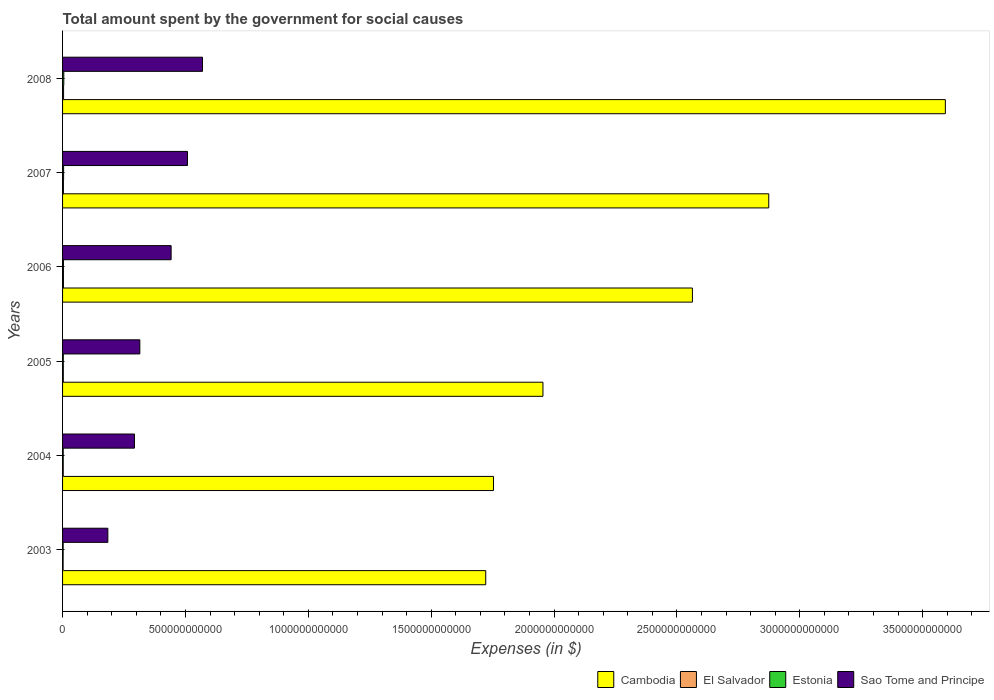Are the number of bars per tick equal to the number of legend labels?
Provide a succinct answer. Yes. Are the number of bars on each tick of the Y-axis equal?
Your answer should be compact. Yes. How many bars are there on the 4th tick from the bottom?
Ensure brevity in your answer.  4. In how many cases, is the number of bars for a given year not equal to the number of legend labels?
Offer a terse response. 0. What is the amount spent for social causes by the government in Estonia in 2005?
Offer a terse response. 2.99e+09. Across all years, what is the maximum amount spent for social causes by the government in Sao Tome and Principe?
Your answer should be compact. 5.69e+11. Across all years, what is the minimum amount spent for social causes by the government in Estonia?
Ensure brevity in your answer.  2.40e+09. In which year was the amount spent for social causes by the government in Estonia minimum?
Your answer should be compact. 2003. What is the total amount spent for social causes by the government in El Salvador in the graph?
Provide a succinct answer. 1.92e+1. What is the difference between the amount spent for social causes by the government in El Salvador in 2003 and that in 2006?
Keep it short and to the point. -1.31e+09. What is the difference between the amount spent for social causes by the government in Estonia in 2004 and the amount spent for social causes by the government in El Salvador in 2006?
Give a very brief answer. -9.47e+08. What is the average amount spent for social causes by the government in Cambodia per year?
Ensure brevity in your answer.  2.41e+12. In the year 2003, what is the difference between the amount spent for social causes by the government in Cambodia and amount spent for social causes by the government in Sao Tome and Principe?
Offer a very short reply. 1.54e+12. In how many years, is the amount spent for social causes by the government in El Salvador greater than 800000000000 $?
Ensure brevity in your answer.  0. What is the ratio of the amount spent for social causes by the government in Cambodia in 2004 to that in 2005?
Provide a succinct answer. 0.9. What is the difference between the highest and the second highest amount spent for social causes by the government in El Salvador?
Your answer should be compact. 4.88e+08. What is the difference between the highest and the lowest amount spent for social causes by the government in Cambodia?
Provide a succinct answer. 1.87e+12. In how many years, is the amount spent for social causes by the government in Sao Tome and Principe greater than the average amount spent for social causes by the government in Sao Tome and Principe taken over all years?
Ensure brevity in your answer.  3. Is the sum of the amount spent for social causes by the government in Sao Tome and Principe in 2005 and 2008 greater than the maximum amount spent for social causes by the government in Estonia across all years?
Keep it short and to the point. Yes. What does the 4th bar from the top in 2006 represents?
Provide a succinct answer. Cambodia. What does the 2nd bar from the bottom in 2004 represents?
Your answer should be very brief. El Salvador. Is it the case that in every year, the sum of the amount spent for social causes by the government in El Salvador and amount spent for social causes by the government in Estonia is greater than the amount spent for social causes by the government in Sao Tome and Principe?
Your response must be concise. No. How many years are there in the graph?
Provide a short and direct response. 6. What is the difference between two consecutive major ticks on the X-axis?
Your answer should be compact. 5.00e+11. Are the values on the major ticks of X-axis written in scientific E-notation?
Provide a short and direct response. No. Does the graph contain grids?
Your response must be concise. No. Where does the legend appear in the graph?
Give a very brief answer. Bottom right. How many legend labels are there?
Offer a very short reply. 4. How are the legend labels stacked?
Your answer should be compact. Horizontal. What is the title of the graph?
Offer a very short reply. Total amount spent by the government for social causes. What is the label or title of the X-axis?
Your answer should be compact. Expenses (in $). What is the Expenses (in $) in Cambodia in 2003?
Offer a very short reply. 1.72e+12. What is the Expenses (in $) in El Salvador in 2003?
Give a very brief answer. 2.30e+09. What is the Expenses (in $) of Estonia in 2003?
Offer a very short reply. 2.40e+09. What is the Expenses (in $) of Sao Tome and Principe in 2003?
Provide a short and direct response. 1.84e+11. What is the Expenses (in $) in Cambodia in 2004?
Your response must be concise. 1.75e+12. What is the Expenses (in $) in El Salvador in 2004?
Your response must be concise. 2.69e+09. What is the Expenses (in $) of Estonia in 2004?
Offer a terse response. 2.66e+09. What is the Expenses (in $) of Sao Tome and Principe in 2004?
Keep it short and to the point. 2.93e+11. What is the Expenses (in $) of Cambodia in 2005?
Your answer should be compact. 1.95e+12. What is the Expenses (in $) of El Salvador in 2005?
Provide a short and direct response. 3.01e+09. What is the Expenses (in $) of Estonia in 2005?
Your answer should be very brief. 2.99e+09. What is the Expenses (in $) of Sao Tome and Principe in 2005?
Offer a terse response. 3.14e+11. What is the Expenses (in $) in Cambodia in 2006?
Your response must be concise. 2.56e+12. What is the Expenses (in $) in El Salvador in 2006?
Your response must be concise. 3.60e+09. What is the Expenses (in $) of Estonia in 2006?
Offer a very short reply. 3.56e+09. What is the Expenses (in $) of Sao Tome and Principe in 2006?
Your answer should be very brief. 4.42e+11. What is the Expenses (in $) of Cambodia in 2007?
Give a very brief answer. 2.87e+12. What is the Expenses (in $) of El Salvador in 2007?
Your answer should be very brief. 3.49e+09. What is the Expenses (in $) of Estonia in 2007?
Your response must be concise. 4.25e+09. What is the Expenses (in $) in Sao Tome and Principe in 2007?
Your answer should be compact. 5.08e+11. What is the Expenses (in $) in Cambodia in 2008?
Ensure brevity in your answer.  3.59e+12. What is the Expenses (in $) in El Salvador in 2008?
Provide a short and direct response. 4.09e+09. What is the Expenses (in $) of Estonia in 2008?
Make the answer very short. 5.00e+09. What is the Expenses (in $) of Sao Tome and Principe in 2008?
Provide a succinct answer. 5.69e+11. Across all years, what is the maximum Expenses (in $) of Cambodia?
Offer a terse response. 3.59e+12. Across all years, what is the maximum Expenses (in $) of El Salvador?
Keep it short and to the point. 4.09e+09. Across all years, what is the maximum Expenses (in $) in Estonia?
Keep it short and to the point. 5.00e+09. Across all years, what is the maximum Expenses (in $) in Sao Tome and Principe?
Make the answer very short. 5.69e+11. Across all years, what is the minimum Expenses (in $) of Cambodia?
Offer a very short reply. 1.72e+12. Across all years, what is the minimum Expenses (in $) of El Salvador?
Provide a short and direct response. 2.30e+09. Across all years, what is the minimum Expenses (in $) in Estonia?
Your answer should be very brief. 2.40e+09. Across all years, what is the minimum Expenses (in $) of Sao Tome and Principe?
Give a very brief answer. 1.84e+11. What is the total Expenses (in $) of Cambodia in the graph?
Keep it short and to the point. 1.45e+13. What is the total Expenses (in $) in El Salvador in the graph?
Provide a succinct answer. 1.92e+1. What is the total Expenses (in $) in Estonia in the graph?
Provide a succinct answer. 2.09e+1. What is the total Expenses (in $) in Sao Tome and Principe in the graph?
Keep it short and to the point. 2.31e+12. What is the difference between the Expenses (in $) of Cambodia in 2003 and that in 2004?
Make the answer very short. -3.16e+1. What is the difference between the Expenses (in $) of El Salvador in 2003 and that in 2004?
Offer a terse response. -3.95e+08. What is the difference between the Expenses (in $) of Estonia in 2003 and that in 2004?
Provide a succinct answer. -2.58e+08. What is the difference between the Expenses (in $) in Sao Tome and Principe in 2003 and that in 2004?
Ensure brevity in your answer.  -1.08e+11. What is the difference between the Expenses (in $) of Cambodia in 2003 and that in 2005?
Your response must be concise. -2.33e+11. What is the difference between the Expenses (in $) in El Salvador in 2003 and that in 2005?
Provide a succinct answer. -7.12e+08. What is the difference between the Expenses (in $) of Estonia in 2003 and that in 2005?
Your answer should be compact. -5.91e+08. What is the difference between the Expenses (in $) in Sao Tome and Principe in 2003 and that in 2005?
Make the answer very short. -1.30e+11. What is the difference between the Expenses (in $) of Cambodia in 2003 and that in 2006?
Your answer should be compact. -8.41e+11. What is the difference between the Expenses (in $) in El Salvador in 2003 and that in 2006?
Provide a short and direct response. -1.31e+09. What is the difference between the Expenses (in $) of Estonia in 2003 and that in 2006?
Keep it short and to the point. -1.16e+09. What is the difference between the Expenses (in $) in Sao Tome and Principe in 2003 and that in 2006?
Your response must be concise. -2.58e+11. What is the difference between the Expenses (in $) in Cambodia in 2003 and that in 2007?
Your answer should be very brief. -1.15e+12. What is the difference between the Expenses (in $) in El Salvador in 2003 and that in 2007?
Give a very brief answer. -1.20e+09. What is the difference between the Expenses (in $) of Estonia in 2003 and that in 2007?
Make the answer very short. -1.85e+09. What is the difference between the Expenses (in $) of Sao Tome and Principe in 2003 and that in 2007?
Ensure brevity in your answer.  -3.24e+11. What is the difference between the Expenses (in $) in Cambodia in 2003 and that in 2008?
Your answer should be compact. -1.87e+12. What is the difference between the Expenses (in $) of El Salvador in 2003 and that in 2008?
Ensure brevity in your answer.  -1.80e+09. What is the difference between the Expenses (in $) in Estonia in 2003 and that in 2008?
Your answer should be compact. -2.60e+09. What is the difference between the Expenses (in $) in Sao Tome and Principe in 2003 and that in 2008?
Provide a succinct answer. -3.85e+11. What is the difference between the Expenses (in $) in Cambodia in 2004 and that in 2005?
Keep it short and to the point. -2.01e+11. What is the difference between the Expenses (in $) of El Salvador in 2004 and that in 2005?
Ensure brevity in your answer.  -3.17e+08. What is the difference between the Expenses (in $) in Estonia in 2004 and that in 2005?
Provide a succinct answer. -3.34e+08. What is the difference between the Expenses (in $) in Sao Tome and Principe in 2004 and that in 2005?
Provide a short and direct response. -2.18e+1. What is the difference between the Expenses (in $) of Cambodia in 2004 and that in 2006?
Keep it short and to the point. -8.10e+11. What is the difference between the Expenses (in $) in El Salvador in 2004 and that in 2006?
Give a very brief answer. -9.12e+08. What is the difference between the Expenses (in $) in Estonia in 2004 and that in 2006?
Provide a succinct answer. -9.03e+08. What is the difference between the Expenses (in $) in Sao Tome and Principe in 2004 and that in 2006?
Your answer should be very brief. -1.49e+11. What is the difference between the Expenses (in $) in Cambodia in 2004 and that in 2007?
Your answer should be very brief. -1.12e+12. What is the difference between the Expenses (in $) of El Salvador in 2004 and that in 2007?
Give a very brief answer. -8.02e+08. What is the difference between the Expenses (in $) of Estonia in 2004 and that in 2007?
Make the answer very short. -1.59e+09. What is the difference between the Expenses (in $) of Sao Tome and Principe in 2004 and that in 2007?
Your response must be concise. -2.16e+11. What is the difference between the Expenses (in $) of Cambodia in 2004 and that in 2008?
Give a very brief answer. -1.84e+12. What is the difference between the Expenses (in $) in El Salvador in 2004 and that in 2008?
Offer a terse response. -1.40e+09. What is the difference between the Expenses (in $) of Estonia in 2004 and that in 2008?
Give a very brief answer. -2.35e+09. What is the difference between the Expenses (in $) of Sao Tome and Principe in 2004 and that in 2008?
Ensure brevity in your answer.  -2.77e+11. What is the difference between the Expenses (in $) in Cambodia in 2005 and that in 2006?
Keep it short and to the point. -6.08e+11. What is the difference between the Expenses (in $) in El Salvador in 2005 and that in 2006?
Make the answer very short. -5.95e+08. What is the difference between the Expenses (in $) in Estonia in 2005 and that in 2006?
Your answer should be compact. -5.69e+08. What is the difference between the Expenses (in $) in Sao Tome and Principe in 2005 and that in 2006?
Offer a very short reply. -1.27e+11. What is the difference between the Expenses (in $) of Cambodia in 2005 and that in 2007?
Ensure brevity in your answer.  -9.19e+11. What is the difference between the Expenses (in $) in El Salvador in 2005 and that in 2007?
Your answer should be compact. -4.85e+08. What is the difference between the Expenses (in $) of Estonia in 2005 and that in 2007?
Your answer should be compact. -1.26e+09. What is the difference between the Expenses (in $) of Sao Tome and Principe in 2005 and that in 2007?
Your answer should be very brief. -1.94e+11. What is the difference between the Expenses (in $) in Cambodia in 2005 and that in 2008?
Offer a very short reply. -1.64e+12. What is the difference between the Expenses (in $) in El Salvador in 2005 and that in 2008?
Offer a very short reply. -1.08e+09. What is the difference between the Expenses (in $) in Estonia in 2005 and that in 2008?
Keep it short and to the point. -2.01e+09. What is the difference between the Expenses (in $) of Sao Tome and Principe in 2005 and that in 2008?
Provide a succinct answer. -2.55e+11. What is the difference between the Expenses (in $) of Cambodia in 2006 and that in 2007?
Offer a terse response. -3.11e+11. What is the difference between the Expenses (in $) of El Salvador in 2006 and that in 2007?
Your response must be concise. 1.10e+08. What is the difference between the Expenses (in $) in Estonia in 2006 and that in 2007?
Provide a short and direct response. -6.92e+08. What is the difference between the Expenses (in $) of Sao Tome and Principe in 2006 and that in 2007?
Offer a very short reply. -6.67e+1. What is the difference between the Expenses (in $) of Cambodia in 2006 and that in 2008?
Ensure brevity in your answer.  -1.03e+12. What is the difference between the Expenses (in $) of El Salvador in 2006 and that in 2008?
Provide a short and direct response. -4.88e+08. What is the difference between the Expenses (in $) in Estonia in 2006 and that in 2008?
Your answer should be very brief. -1.44e+09. What is the difference between the Expenses (in $) of Sao Tome and Principe in 2006 and that in 2008?
Offer a terse response. -1.28e+11. What is the difference between the Expenses (in $) in Cambodia in 2007 and that in 2008?
Provide a short and direct response. -7.19e+11. What is the difference between the Expenses (in $) of El Salvador in 2007 and that in 2008?
Offer a very short reply. -5.98e+08. What is the difference between the Expenses (in $) in Estonia in 2007 and that in 2008?
Your answer should be very brief. -7.51e+08. What is the difference between the Expenses (in $) of Sao Tome and Principe in 2007 and that in 2008?
Offer a terse response. -6.10e+1. What is the difference between the Expenses (in $) in Cambodia in 2003 and the Expenses (in $) in El Salvador in 2004?
Give a very brief answer. 1.72e+12. What is the difference between the Expenses (in $) of Cambodia in 2003 and the Expenses (in $) of Estonia in 2004?
Make the answer very short. 1.72e+12. What is the difference between the Expenses (in $) in Cambodia in 2003 and the Expenses (in $) in Sao Tome and Principe in 2004?
Provide a short and direct response. 1.43e+12. What is the difference between the Expenses (in $) in El Salvador in 2003 and the Expenses (in $) in Estonia in 2004?
Offer a terse response. -3.60e+08. What is the difference between the Expenses (in $) of El Salvador in 2003 and the Expenses (in $) of Sao Tome and Principe in 2004?
Make the answer very short. -2.90e+11. What is the difference between the Expenses (in $) of Estonia in 2003 and the Expenses (in $) of Sao Tome and Principe in 2004?
Provide a short and direct response. -2.90e+11. What is the difference between the Expenses (in $) of Cambodia in 2003 and the Expenses (in $) of El Salvador in 2005?
Your answer should be compact. 1.72e+12. What is the difference between the Expenses (in $) in Cambodia in 2003 and the Expenses (in $) in Estonia in 2005?
Provide a succinct answer. 1.72e+12. What is the difference between the Expenses (in $) in Cambodia in 2003 and the Expenses (in $) in Sao Tome and Principe in 2005?
Your answer should be compact. 1.41e+12. What is the difference between the Expenses (in $) in El Salvador in 2003 and the Expenses (in $) in Estonia in 2005?
Make the answer very short. -6.94e+08. What is the difference between the Expenses (in $) of El Salvador in 2003 and the Expenses (in $) of Sao Tome and Principe in 2005?
Give a very brief answer. -3.12e+11. What is the difference between the Expenses (in $) of Estonia in 2003 and the Expenses (in $) of Sao Tome and Principe in 2005?
Give a very brief answer. -3.12e+11. What is the difference between the Expenses (in $) of Cambodia in 2003 and the Expenses (in $) of El Salvador in 2006?
Offer a very short reply. 1.72e+12. What is the difference between the Expenses (in $) in Cambodia in 2003 and the Expenses (in $) in Estonia in 2006?
Offer a very short reply. 1.72e+12. What is the difference between the Expenses (in $) of Cambodia in 2003 and the Expenses (in $) of Sao Tome and Principe in 2006?
Your response must be concise. 1.28e+12. What is the difference between the Expenses (in $) of El Salvador in 2003 and the Expenses (in $) of Estonia in 2006?
Provide a succinct answer. -1.26e+09. What is the difference between the Expenses (in $) in El Salvador in 2003 and the Expenses (in $) in Sao Tome and Principe in 2006?
Offer a very short reply. -4.39e+11. What is the difference between the Expenses (in $) of Estonia in 2003 and the Expenses (in $) of Sao Tome and Principe in 2006?
Keep it short and to the point. -4.39e+11. What is the difference between the Expenses (in $) of Cambodia in 2003 and the Expenses (in $) of El Salvador in 2007?
Your answer should be compact. 1.72e+12. What is the difference between the Expenses (in $) of Cambodia in 2003 and the Expenses (in $) of Estonia in 2007?
Provide a succinct answer. 1.72e+12. What is the difference between the Expenses (in $) of Cambodia in 2003 and the Expenses (in $) of Sao Tome and Principe in 2007?
Give a very brief answer. 1.21e+12. What is the difference between the Expenses (in $) in El Salvador in 2003 and the Expenses (in $) in Estonia in 2007?
Provide a succinct answer. -1.95e+09. What is the difference between the Expenses (in $) in El Salvador in 2003 and the Expenses (in $) in Sao Tome and Principe in 2007?
Keep it short and to the point. -5.06e+11. What is the difference between the Expenses (in $) of Estonia in 2003 and the Expenses (in $) of Sao Tome and Principe in 2007?
Make the answer very short. -5.06e+11. What is the difference between the Expenses (in $) in Cambodia in 2003 and the Expenses (in $) in El Salvador in 2008?
Offer a very short reply. 1.72e+12. What is the difference between the Expenses (in $) in Cambodia in 2003 and the Expenses (in $) in Estonia in 2008?
Your response must be concise. 1.72e+12. What is the difference between the Expenses (in $) of Cambodia in 2003 and the Expenses (in $) of Sao Tome and Principe in 2008?
Give a very brief answer. 1.15e+12. What is the difference between the Expenses (in $) in El Salvador in 2003 and the Expenses (in $) in Estonia in 2008?
Ensure brevity in your answer.  -2.71e+09. What is the difference between the Expenses (in $) in El Salvador in 2003 and the Expenses (in $) in Sao Tome and Principe in 2008?
Make the answer very short. -5.67e+11. What is the difference between the Expenses (in $) in Estonia in 2003 and the Expenses (in $) in Sao Tome and Principe in 2008?
Keep it short and to the point. -5.67e+11. What is the difference between the Expenses (in $) of Cambodia in 2004 and the Expenses (in $) of El Salvador in 2005?
Make the answer very short. 1.75e+12. What is the difference between the Expenses (in $) in Cambodia in 2004 and the Expenses (in $) in Estonia in 2005?
Your answer should be very brief. 1.75e+12. What is the difference between the Expenses (in $) in Cambodia in 2004 and the Expenses (in $) in Sao Tome and Principe in 2005?
Your answer should be very brief. 1.44e+12. What is the difference between the Expenses (in $) in El Salvador in 2004 and the Expenses (in $) in Estonia in 2005?
Your answer should be compact. -2.98e+08. What is the difference between the Expenses (in $) in El Salvador in 2004 and the Expenses (in $) in Sao Tome and Principe in 2005?
Make the answer very short. -3.12e+11. What is the difference between the Expenses (in $) in Estonia in 2004 and the Expenses (in $) in Sao Tome and Principe in 2005?
Your answer should be compact. -3.12e+11. What is the difference between the Expenses (in $) of Cambodia in 2004 and the Expenses (in $) of El Salvador in 2006?
Keep it short and to the point. 1.75e+12. What is the difference between the Expenses (in $) of Cambodia in 2004 and the Expenses (in $) of Estonia in 2006?
Ensure brevity in your answer.  1.75e+12. What is the difference between the Expenses (in $) of Cambodia in 2004 and the Expenses (in $) of Sao Tome and Principe in 2006?
Your answer should be compact. 1.31e+12. What is the difference between the Expenses (in $) of El Salvador in 2004 and the Expenses (in $) of Estonia in 2006?
Make the answer very short. -8.67e+08. What is the difference between the Expenses (in $) of El Salvador in 2004 and the Expenses (in $) of Sao Tome and Principe in 2006?
Provide a short and direct response. -4.39e+11. What is the difference between the Expenses (in $) of Estonia in 2004 and the Expenses (in $) of Sao Tome and Principe in 2006?
Provide a short and direct response. -4.39e+11. What is the difference between the Expenses (in $) in Cambodia in 2004 and the Expenses (in $) in El Salvador in 2007?
Provide a short and direct response. 1.75e+12. What is the difference between the Expenses (in $) of Cambodia in 2004 and the Expenses (in $) of Estonia in 2007?
Offer a terse response. 1.75e+12. What is the difference between the Expenses (in $) of Cambodia in 2004 and the Expenses (in $) of Sao Tome and Principe in 2007?
Ensure brevity in your answer.  1.25e+12. What is the difference between the Expenses (in $) in El Salvador in 2004 and the Expenses (in $) in Estonia in 2007?
Your answer should be compact. -1.56e+09. What is the difference between the Expenses (in $) in El Salvador in 2004 and the Expenses (in $) in Sao Tome and Principe in 2007?
Keep it short and to the point. -5.06e+11. What is the difference between the Expenses (in $) in Estonia in 2004 and the Expenses (in $) in Sao Tome and Principe in 2007?
Offer a very short reply. -5.06e+11. What is the difference between the Expenses (in $) in Cambodia in 2004 and the Expenses (in $) in El Salvador in 2008?
Provide a short and direct response. 1.75e+12. What is the difference between the Expenses (in $) in Cambodia in 2004 and the Expenses (in $) in Estonia in 2008?
Keep it short and to the point. 1.75e+12. What is the difference between the Expenses (in $) in Cambodia in 2004 and the Expenses (in $) in Sao Tome and Principe in 2008?
Provide a succinct answer. 1.18e+12. What is the difference between the Expenses (in $) of El Salvador in 2004 and the Expenses (in $) of Estonia in 2008?
Offer a terse response. -2.31e+09. What is the difference between the Expenses (in $) in El Salvador in 2004 and the Expenses (in $) in Sao Tome and Principe in 2008?
Provide a succinct answer. -5.67e+11. What is the difference between the Expenses (in $) of Estonia in 2004 and the Expenses (in $) of Sao Tome and Principe in 2008?
Offer a terse response. -5.67e+11. What is the difference between the Expenses (in $) in Cambodia in 2005 and the Expenses (in $) in El Salvador in 2006?
Provide a short and direct response. 1.95e+12. What is the difference between the Expenses (in $) of Cambodia in 2005 and the Expenses (in $) of Estonia in 2006?
Your answer should be very brief. 1.95e+12. What is the difference between the Expenses (in $) in Cambodia in 2005 and the Expenses (in $) in Sao Tome and Principe in 2006?
Keep it short and to the point. 1.51e+12. What is the difference between the Expenses (in $) of El Salvador in 2005 and the Expenses (in $) of Estonia in 2006?
Ensure brevity in your answer.  -5.50e+08. What is the difference between the Expenses (in $) in El Salvador in 2005 and the Expenses (in $) in Sao Tome and Principe in 2006?
Your answer should be very brief. -4.39e+11. What is the difference between the Expenses (in $) of Estonia in 2005 and the Expenses (in $) of Sao Tome and Principe in 2006?
Provide a succinct answer. -4.39e+11. What is the difference between the Expenses (in $) of Cambodia in 2005 and the Expenses (in $) of El Salvador in 2007?
Your answer should be compact. 1.95e+12. What is the difference between the Expenses (in $) of Cambodia in 2005 and the Expenses (in $) of Estonia in 2007?
Provide a succinct answer. 1.95e+12. What is the difference between the Expenses (in $) of Cambodia in 2005 and the Expenses (in $) of Sao Tome and Principe in 2007?
Provide a succinct answer. 1.45e+12. What is the difference between the Expenses (in $) in El Salvador in 2005 and the Expenses (in $) in Estonia in 2007?
Provide a short and direct response. -1.24e+09. What is the difference between the Expenses (in $) of El Salvador in 2005 and the Expenses (in $) of Sao Tome and Principe in 2007?
Provide a short and direct response. -5.05e+11. What is the difference between the Expenses (in $) of Estonia in 2005 and the Expenses (in $) of Sao Tome and Principe in 2007?
Give a very brief answer. -5.05e+11. What is the difference between the Expenses (in $) of Cambodia in 2005 and the Expenses (in $) of El Salvador in 2008?
Ensure brevity in your answer.  1.95e+12. What is the difference between the Expenses (in $) in Cambodia in 2005 and the Expenses (in $) in Estonia in 2008?
Offer a terse response. 1.95e+12. What is the difference between the Expenses (in $) in Cambodia in 2005 and the Expenses (in $) in Sao Tome and Principe in 2008?
Offer a very short reply. 1.39e+12. What is the difference between the Expenses (in $) in El Salvador in 2005 and the Expenses (in $) in Estonia in 2008?
Your answer should be very brief. -1.99e+09. What is the difference between the Expenses (in $) in El Salvador in 2005 and the Expenses (in $) in Sao Tome and Principe in 2008?
Ensure brevity in your answer.  -5.66e+11. What is the difference between the Expenses (in $) of Estonia in 2005 and the Expenses (in $) of Sao Tome and Principe in 2008?
Your answer should be compact. -5.66e+11. What is the difference between the Expenses (in $) of Cambodia in 2006 and the Expenses (in $) of El Salvador in 2007?
Offer a terse response. 2.56e+12. What is the difference between the Expenses (in $) in Cambodia in 2006 and the Expenses (in $) in Estonia in 2007?
Your response must be concise. 2.56e+12. What is the difference between the Expenses (in $) in Cambodia in 2006 and the Expenses (in $) in Sao Tome and Principe in 2007?
Your answer should be compact. 2.05e+12. What is the difference between the Expenses (in $) in El Salvador in 2006 and the Expenses (in $) in Estonia in 2007?
Provide a short and direct response. -6.47e+08. What is the difference between the Expenses (in $) of El Salvador in 2006 and the Expenses (in $) of Sao Tome and Principe in 2007?
Keep it short and to the point. -5.05e+11. What is the difference between the Expenses (in $) of Estonia in 2006 and the Expenses (in $) of Sao Tome and Principe in 2007?
Provide a short and direct response. -5.05e+11. What is the difference between the Expenses (in $) in Cambodia in 2006 and the Expenses (in $) in El Salvador in 2008?
Ensure brevity in your answer.  2.56e+12. What is the difference between the Expenses (in $) in Cambodia in 2006 and the Expenses (in $) in Estonia in 2008?
Offer a very short reply. 2.56e+12. What is the difference between the Expenses (in $) in Cambodia in 2006 and the Expenses (in $) in Sao Tome and Principe in 2008?
Give a very brief answer. 1.99e+12. What is the difference between the Expenses (in $) in El Salvador in 2006 and the Expenses (in $) in Estonia in 2008?
Keep it short and to the point. -1.40e+09. What is the difference between the Expenses (in $) in El Salvador in 2006 and the Expenses (in $) in Sao Tome and Principe in 2008?
Make the answer very short. -5.66e+11. What is the difference between the Expenses (in $) in Estonia in 2006 and the Expenses (in $) in Sao Tome and Principe in 2008?
Give a very brief answer. -5.66e+11. What is the difference between the Expenses (in $) in Cambodia in 2007 and the Expenses (in $) in El Salvador in 2008?
Your answer should be very brief. 2.87e+12. What is the difference between the Expenses (in $) in Cambodia in 2007 and the Expenses (in $) in Estonia in 2008?
Offer a very short reply. 2.87e+12. What is the difference between the Expenses (in $) of Cambodia in 2007 and the Expenses (in $) of Sao Tome and Principe in 2008?
Give a very brief answer. 2.30e+12. What is the difference between the Expenses (in $) of El Salvador in 2007 and the Expenses (in $) of Estonia in 2008?
Ensure brevity in your answer.  -1.51e+09. What is the difference between the Expenses (in $) of El Salvador in 2007 and the Expenses (in $) of Sao Tome and Principe in 2008?
Offer a terse response. -5.66e+11. What is the difference between the Expenses (in $) of Estonia in 2007 and the Expenses (in $) of Sao Tome and Principe in 2008?
Give a very brief answer. -5.65e+11. What is the average Expenses (in $) of Cambodia per year?
Give a very brief answer. 2.41e+12. What is the average Expenses (in $) in El Salvador per year?
Your answer should be very brief. 3.20e+09. What is the average Expenses (in $) in Estonia per year?
Give a very brief answer. 3.48e+09. What is the average Expenses (in $) in Sao Tome and Principe per year?
Offer a terse response. 3.85e+11. In the year 2003, what is the difference between the Expenses (in $) of Cambodia and Expenses (in $) of El Salvador?
Your response must be concise. 1.72e+12. In the year 2003, what is the difference between the Expenses (in $) of Cambodia and Expenses (in $) of Estonia?
Your response must be concise. 1.72e+12. In the year 2003, what is the difference between the Expenses (in $) of Cambodia and Expenses (in $) of Sao Tome and Principe?
Give a very brief answer. 1.54e+12. In the year 2003, what is the difference between the Expenses (in $) in El Salvador and Expenses (in $) in Estonia?
Provide a succinct answer. -1.02e+08. In the year 2003, what is the difference between the Expenses (in $) in El Salvador and Expenses (in $) in Sao Tome and Principe?
Offer a terse response. -1.82e+11. In the year 2003, what is the difference between the Expenses (in $) in Estonia and Expenses (in $) in Sao Tome and Principe?
Ensure brevity in your answer.  -1.82e+11. In the year 2004, what is the difference between the Expenses (in $) of Cambodia and Expenses (in $) of El Salvador?
Your answer should be very brief. 1.75e+12. In the year 2004, what is the difference between the Expenses (in $) of Cambodia and Expenses (in $) of Estonia?
Ensure brevity in your answer.  1.75e+12. In the year 2004, what is the difference between the Expenses (in $) in Cambodia and Expenses (in $) in Sao Tome and Principe?
Keep it short and to the point. 1.46e+12. In the year 2004, what is the difference between the Expenses (in $) in El Salvador and Expenses (in $) in Estonia?
Your answer should be very brief. 3.52e+07. In the year 2004, what is the difference between the Expenses (in $) of El Salvador and Expenses (in $) of Sao Tome and Principe?
Keep it short and to the point. -2.90e+11. In the year 2004, what is the difference between the Expenses (in $) in Estonia and Expenses (in $) in Sao Tome and Principe?
Ensure brevity in your answer.  -2.90e+11. In the year 2005, what is the difference between the Expenses (in $) of Cambodia and Expenses (in $) of El Salvador?
Your answer should be very brief. 1.95e+12. In the year 2005, what is the difference between the Expenses (in $) in Cambodia and Expenses (in $) in Estonia?
Offer a very short reply. 1.95e+12. In the year 2005, what is the difference between the Expenses (in $) in Cambodia and Expenses (in $) in Sao Tome and Principe?
Your answer should be very brief. 1.64e+12. In the year 2005, what is the difference between the Expenses (in $) of El Salvador and Expenses (in $) of Estonia?
Your answer should be very brief. 1.87e+07. In the year 2005, what is the difference between the Expenses (in $) of El Salvador and Expenses (in $) of Sao Tome and Principe?
Offer a very short reply. -3.11e+11. In the year 2005, what is the difference between the Expenses (in $) of Estonia and Expenses (in $) of Sao Tome and Principe?
Give a very brief answer. -3.11e+11. In the year 2006, what is the difference between the Expenses (in $) in Cambodia and Expenses (in $) in El Salvador?
Make the answer very short. 2.56e+12. In the year 2006, what is the difference between the Expenses (in $) of Cambodia and Expenses (in $) of Estonia?
Your response must be concise. 2.56e+12. In the year 2006, what is the difference between the Expenses (in $) in Cambodia and Expenses (in $) in Sao Tome and Principe?
Your answer should be very brief. 2.12e+12. In the year 2006, what is the difference between the Expenses (in $) in El Salvador and Expenses (in $) in Estonia?
Give a very brief answer. 4.48e+07. In the year 2006, what is the difference between the Expenses (in $) in El Salvador and Expenses (in $) in Sao Tome and Principe?
Keep it short and to the point. -4.38e+11. In the year 2006, what is the difference between the Expenses (in $) in Estonia and Expenses (in $) in Sao Tome and Principe?
Your answer should be very brief. -4.38e+11. In the year 2007, what is the difference between the Expenses (in $) in Cambodia and Expenses (in $) in El Salvador?
Provide a short and direct response. 2.87e+12. In the year 2007, what is the difference between the Expenses (in $) of Cambodia and Expenses (in $) of Estonia?
Ensure brevity in your answer.  2.87e+12. In the year 2007, what is the difference between the Expenses (in $) in Cambodia and Expenses (in $) in Sao Tome and Principe?
Make the answer very short. 2.37e+12. In the year 2007, what is the difference between the Expenses (in $) in El Salvador and Expenses (in $) in Estonia?
Offer a very short reply. -7.57e+08. In the year 2007, what is the difference between the Expenses (in $) of El Salvador and Expenses (in $) of Sao Tome and Principe?
Provide a short and direct response. -5.05e+11. In the year 2007, what is the difference between the Expenses (in $) of Estonia and Expenses (in $) of Sao Tome and Principe?
Give a very brief answer. -5.04e+11. In the year 2008, what is the difference between the Expenses (in $) in Cambodia and Expenses (in $) in El Salvador?
Give a very brief answer. 3.59e+12. In the year 2008, what is the difference between the Expenses (in $) in Cambodia and Expenses (in $) in Estonia?
Ensure brevity in your answer.  3.59e+12. In the year 2008, what is the difference between the Expenses (in $) of Cambodia and Expenses (in $) of Sao Tome and Principe?
Keep it short and to the point. 3.02e+12. In the year 2008, what is the difference between the Expenses (in $) in El Salvador and Expenses (in $) in Estonia?
Your response must be concise. -9.10e+08. In the year 2008, what is the difference between the Expenses (in $) of El Salvador and Expenses (in $) of Sao Tome and Principe?
Your answer should be very brief. -5.65e+11. In the year 2008, what is the difference between the Expenses (in $) of Estonia and Expenses (in $) of Sao Tome and Principe?
Provide a succinct answer. -5.64e+11. What is the ratio of the Expenses (in $) of Cambodia in 2003 to that in 2004?
Offer a very short reply. 0.98. What is the ratio of the Expenses (in $) in El Salvador in 2003 to that in 2004?
Make the answer very short. 0.85. What is the ratio of the Expenses (in $) of Estonia in 2003 to that in 2004?
Your answer should be very brief. 0.9. What is the ratio of the Expenses (in $) in Sao Tome and Principe in 2003 to that in 2004?
Offer a terse response. 0.63. What is the ratio of the Expenses (in $) in Cambodia in 2003 to that in 2005?
Offer a very short reply. 0.88. What is the ratio of the Expenses (in $) of El Salvador in 2003 to that in 2005?
Provide a succinct answer. 0.76. What is the ratio of the Expenses (in $) of Estonia in 2003 to that in 2005?
Make the answer very short. 0.8. What is the ratio of the Expenses (in $) in Sao Tome and Principe in 2003 to that in 2005?
Your answer should be very brief. 0.59. What is the ratio of the Expenses (in $) in Cambodia in 2003 to that in 2006?
Provide a short and direct response. 0.67. What is the ratio of the Expenses (in $) of El Salvador in 2003 to that in 2006?
Offer a very short reply. 0.64. What is the ratio of the Expenses (in $) of Estonia in 2003 to that in 2006?
Give a very brief answer. 0.67. What is the ratio of the Expenses (in $) in Sao Tome and Principe in 2003 to that in 2006?
Your response must be concise. 0.42. What is the ratio of the Expenses (in $) of Cambodia in 2003 to that in 2007?
Ensure brevity in your answer.  0.6. What is the ratio of the Expenses (in $) in El Salvador in 2003 to that in 2007?
Offer a very short reply. 0.66. What is the ratio of the Expenses (in $) in Estonia in 2003 to that in 2007?
Your response must be concise. 0.56. What is the ratio of the Expenses (in $) in Sao Tome and Principe in 2003 to that in 2007?
Your answer should be compact. 0.36. What is the ratio of the Expenses (in $) of Cambodia in 2003 to that in 2008?
Your answer should be compact. 0.48. What is the ratio of the Expenses (in $) in El Salvador in 2003 to that in 2008?
Keep it short and to the point. 0.56. What is the ratio of the Expenses (in $) of Estonia in 2003 to that in 2008?
Provide a succinct answer. 0.48. What is the ratio of the Expenses (in $) of Sao Tome and Principe in 2003 to that in 2008?
Offer a very short reply. 0.32. What is the ratio of the Expenses (in $) of Cambodia in 2004 to that in 2005?
Your answer should be compact. 0.9. What is the ratio of the Expenses (in $) in El Salvador in 2004 to that in 2005?
Offer a terse response. 0.89. What is the ratio of the Expenses (in $) in Estonia in 2004 to that in 2005?
Offer a very short reply. 0.89. What is the ratio of the Expenses (in $) in Sao Tome and Principe in 2004 to that in 2005?
Ensure brevity in your answer.  0.93. What is the ratio of the Expenses (in $) in Cambodia in 2004 to that in 2006?
Provide a succinct answer. 0.68. What is the ratio of the Expenses (in $) of El Salvador in 2004 to that in 2006?
Your answer should be very brief. 0.75. What is the ratio of the Expenses (in $) of Estonia in 2004 to that in 2006?
Provide a succinct answer. 0.75. What is the ratio of the Expenses (in $) of Sao Tome and Principe in 2004 to that in 2006?
Ensure brevity in your answer.  0.66. What is the ratio of the Expenses (in $) of Cambodia in 2004 to that in 2007?
Ensure brevity in your answer.  0.61. What is the ratio of the Expenses (in $) of El Salvador in 2004 to that in 2007?
Provide a succinct answer. 0.77. What is the ratio of the Expenses (in $) in Estonia in 2004 to that in 2007?
Your answer should be very brief. 0.62. What is the ratio of the Expenses (in $) in Sao Tome and Principe in 2004 to that in 2007?
Your answer should be very brief. 0.58. What is the ratio of the Expenses (in $) in Cambodia in 2004 to that in 2008?
Your answer should be very brief. 0.49. What is the ratio of the Expenses (in $) of El Salvador in 2004 to that in 2008?
Offer a very short reply. 0.66. What is the ratio of the Expenses (in $) of Estonia in 2004 to that in 2008?
Ensure brevity in your answer.  0.53. What is the ratio of the Expenses (in $) of Sao Tome and Principe in 2004 to that in 2008?
Provide a short and direct response. 0.51. What is the ratio of the Expenses (in $) of Cambodia in 2005 to that in 2006?
Provide a short and direct response. 0.76. What is the ratio of the Expenses (in $) of El Salvador in 2005 to that in 2006?
Your answer should be compact. 0.83. What is the ratio of the Expenses (in $) in Estonia in 2005 to that in 2006?
Your answer should be very brief. 0.84. What is the ratio of the Expenses (in $) in Sao Tome and Principe in 2005 to that in 2006?
Ensure brevity in your answer.  0.71. What is the ratio of the Expenses (in $) in Cambodia in 2005 to that in 2007?
Offer a terse response. 0.68. What is the ratio of the Expenses (in $) of El Salvador in 2005 to that in 2007?
Your response must be concise. 0.86. What is the ratio of the Expenses (in $) in Estonia in 2005 to that in 2007?
Provide a succinct answer. 0.7. What is the ratio of the Expenses (in $) of Sao Tome and Principe in 2005 to that in 2007?
Offer a terse response. 0.62. What is the ratio of the Expenses (in $) in Cambodia in 2005 to that in 2008?
Offer a terse response. 0.54. What is the ratio of the Expenses (in $) in El Salvador in 2005 to that in 2008?
Keep it short and to the point. 0.74. What is the ratio of the Expenses (in $) in Estonia in 2005 to that in 2008?
Offer a terse response. 0.6. What is the ratio of the Expenses (in $) of Sao Tome and Principe in 2005 to that in 2008?
Provide a short and direct response. 0.55. What is the ratio of the Expenses (in $) in Cambodia in 2006 to that in 2007?
Your answer should be very brief. 0.89. What is the ratio of the Expenses (in $) in El Salvador in 2006 to that in 2007?
Offer a terse response. 1.03. What is the ratio of the Expenses (in $) in Estonia in 2006 to that in 2007?
Provide a succinct answer. 0.84. What is the ratio of the Expenses (in $) in Sao Tome and Principe in 2006 to that in 2007?
Your response must be concise. 0.87. What is the ratio of the Expenses (in $) of Cambodia in 2006 to that in 2008?
Provide a succinct answer. 0.71. What is the ratio of the Expenses (in $) of El Salvador in 2006 to that in 2008?
Your response must be concise. 0.88. What is the ratio of the Expenses (in $) of Estonia in 2006 to that in 2008?
Your response must be concise. 0.71. What is the ratio of the Expenses (in $) of Sao Tome and Principe in 2006 to that in 2008?
Your answer should be compact. 0.78. What is the ratio of the Expenses (in $) in Cambodia in 2007 to that in 2008?
Ensure brevity in your answer.  0.8. What is the ratio of the Expenses (in $) in El Salvador in 2007 to that in 2008?
Offer a very short reply. 0.85. What is the ratio of the Expenses (in $) in Estonia in 2007 to that in 2008?
Ensure brevity in your answer.  0.85. What is the ratio of the Expenses (in $) of Sao Tome and Principe in 2007 to that in 2008?
Your answer should be compact. 0.89. What is the difference between the highest and the second highest Expenses (in $) in Cambodia?
Ensure brevity in your answer.  7.19e+11. What is the difference between the highest and the second highest Expenses (in $) of El Salvador?
Provide a succinct answer. 4.88e+08. What is the difference between the highest and the second highest Expenses (in $) of Estonia?
Your response must be concise. 7.51e+08. What is the difference between the highest and the second highest Expenses (in $) in Sao Tome and Principe?
Keep it short and to the point. 6.10e+1. What is the difference between the highest and the lowest Expenses (in $) in Cambodia?
Your answer should be compact. 1.87e+12. What is the difference between the highest and the lowest Expenses (in $) in El Salvador?
Your answer should be very brief. 1.80e+09. What is the difference between the highest and the lowest Expenses (in $) of Estonia?
Give a very brief answer. 2.60e+09. What is the difference between the highest and the lowest Expenses (in $) of Sao Tome and Principe?
Make the answer very short. 3.85e+11. 